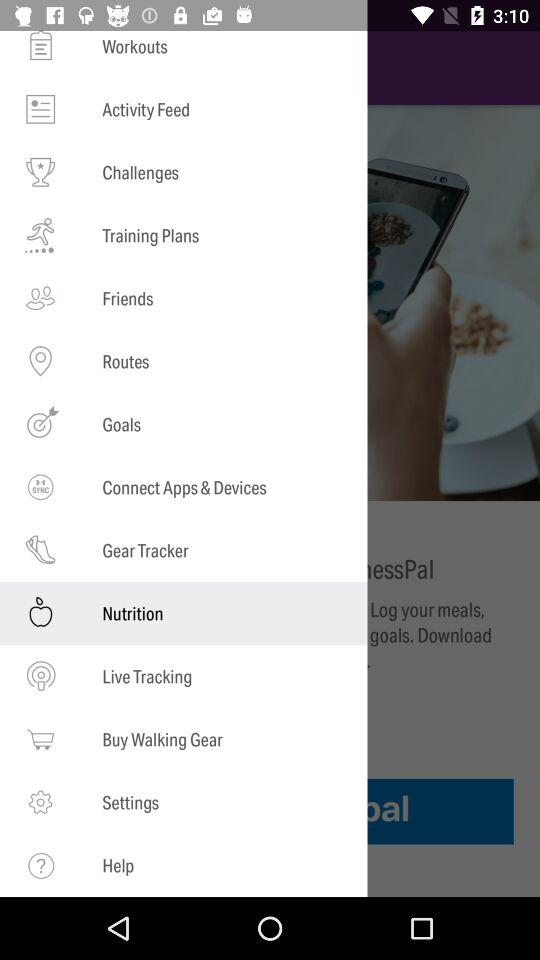What is the selected item? The selected item is "Nutrition". 